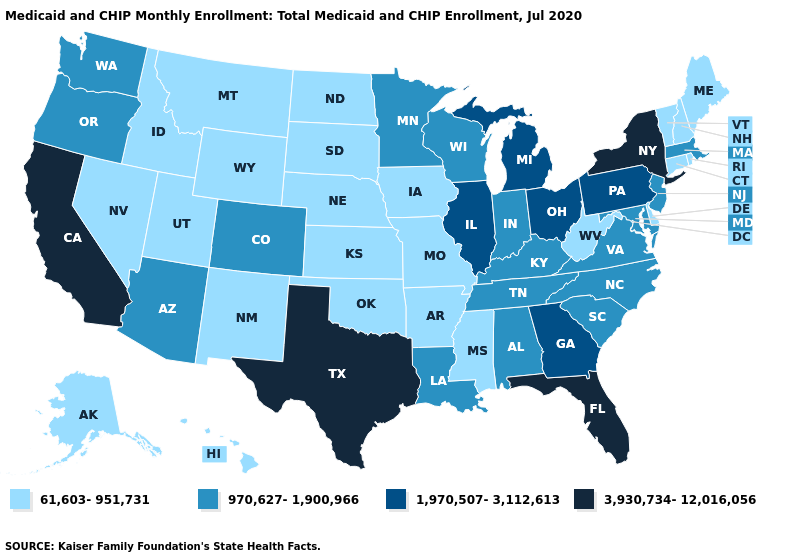Does Delaware have the lowest value in the USA?
Keep it brief. Yes. Among the states that border Michigan , which have the highest value?
Give a very brief answer. Ohio. What is the value of New Hampshire?
Give a very brief answer. 61,603-951,731. Name the states that have a value in the range 61,603-951,731?
Be succinct. Alaska, Arkansas, Connecticut, Delaware, Hawaii, Idaho, Iowa, Kansas, Maine, Mississippi, Missouri, Montana, Nebraska, Nevada, New Hampshire, New Mexico, North Dakota, Oklahoma, Rhode Island, South Dakota, Utah, Vermont, West Virginia, Wyoming. Name the states that have a value in the range 1,970,507-3,112,613?
Be succinct. Georgia, Illinois, Michigan, Ohio, Pennsylvania. Name the states that have a value in the range 3,930,734-12,016,056?
Short answer required. California, Florida, New York, Texas. What is the value of Massachusetts?
Concise answer only. 970,627-1,900,966. What is the value of West Virginia?
Concise answer only. 61,603-951,731. Is the legend a continuous bar?
Give a very brief answer. No. Does Kansas have the lowest value in the MidWest?
Write a very short answer. Yes. Name the states that have a value in the range 1,970,507-3,112,613?
Write a very short answer. Georgia, Illinois, Michigan, Ohio, Pennsylvania. What is the lowest value in the West?
Keep it brief. 61,603-951,731. Name the states that have a value in the range 61,603-951,731?
Answer briefly. Alaska, Arkansas, Connecticut, Delaware, Hawaii, Idaho, Iowa, Kansas, Maine, Mississippi, Missouri, Montana, Nebraska, Nevada, New Hampshire, New Mexico, North Dakota, Oklahoma, Rhode Island, South Dakota, Utah, Vermont, West Virginia, Wyoming. Name the states that have a value in the range 3,930,734-12,016,056?
Keep it brief. California, Florida, New York, Texas. Does the first symbol in the legend represent the smallest category?
Quick response, please. Yes. 